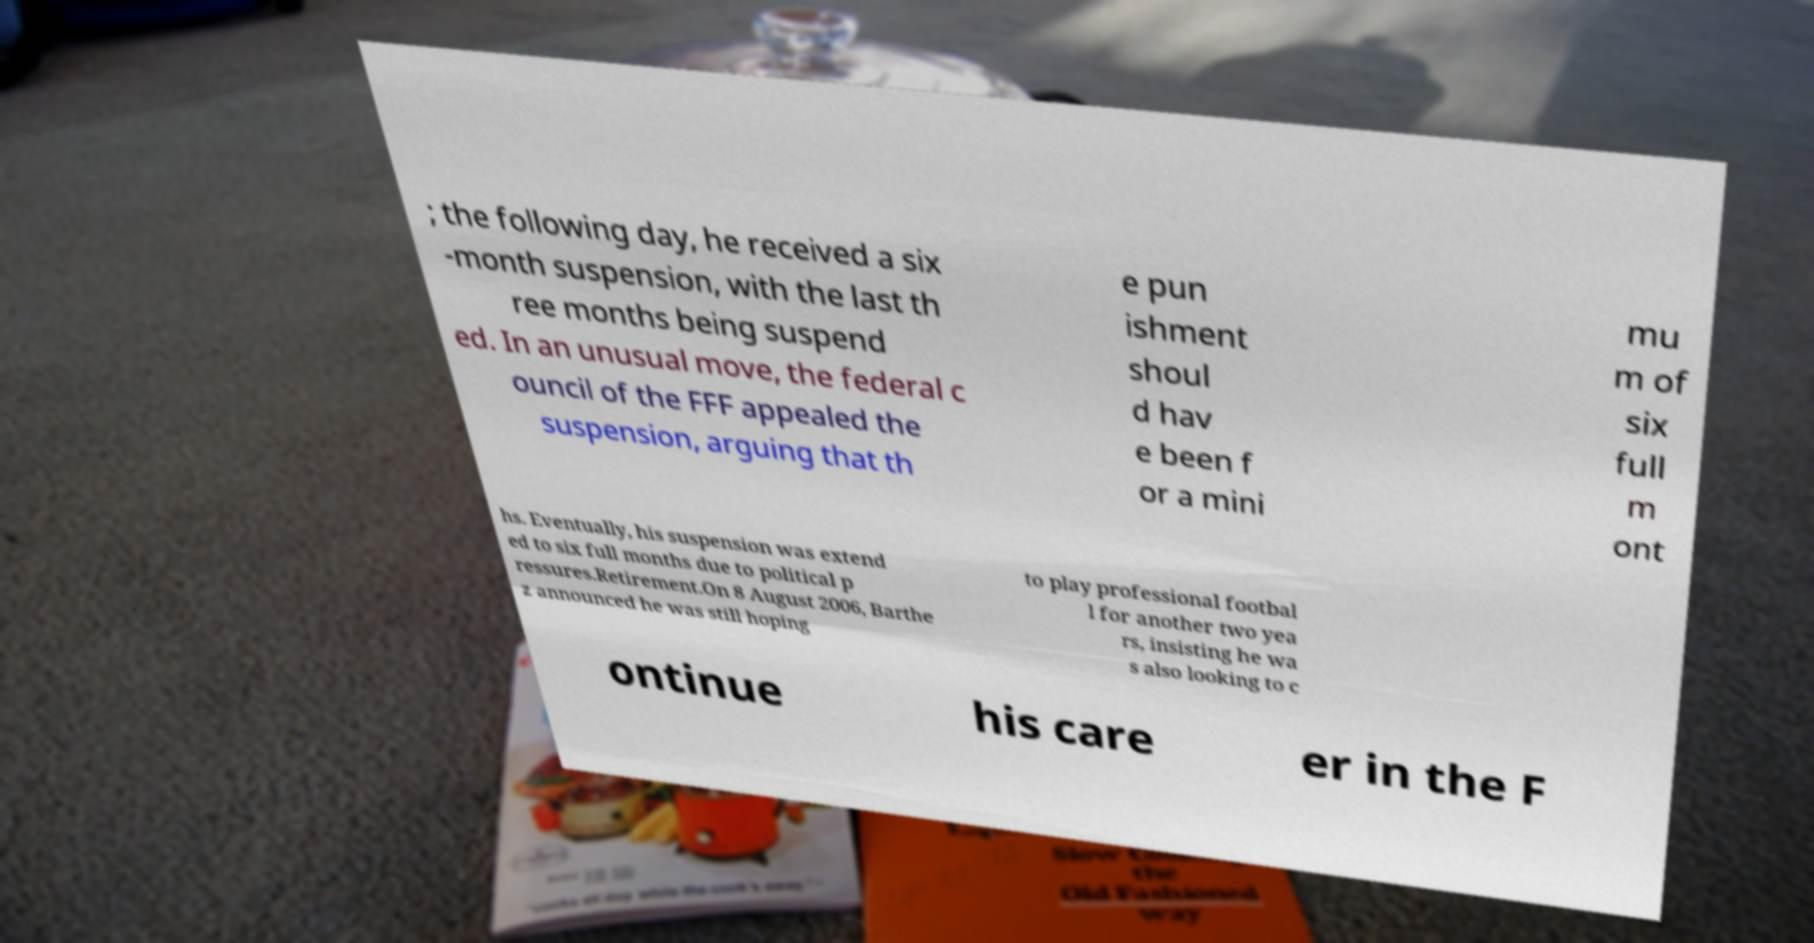Can you accurately transcribe the text from the provided image for me? ; the following day, he received a six -month suspension, with the last th ree months being suspend ed. In an unusual move, the federal c ouncil of the FFF appealed the suspension, arguing that th e pun ishment shoul d hav e been f or a mini mu m of six full m ont hs. Eventually, his suspension was extend ed to six full months due to political p ressures.Retirement.On 8 August 2006, Barthe z announced he was still hoping to play professional footbal l for another two yea rs, insisting he wa s also looking to c ontinue his care er in the F 